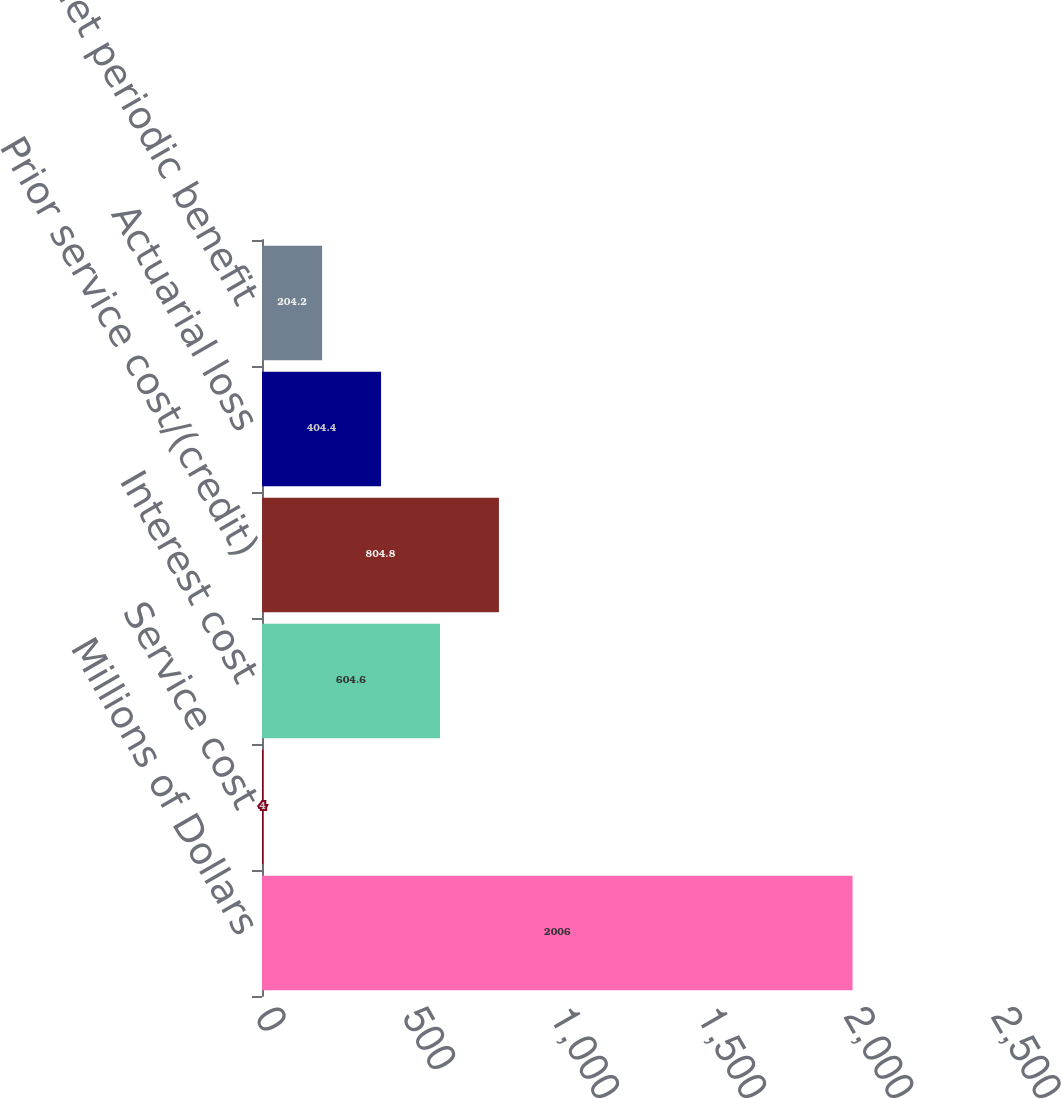Convert chart. <chart><loc_0><loc_0><loc_500><loc_500><bar_chart><fcel>Millions of Dollars<fcel>Service cost<fcel>Interest cost<fcel>Prior service cost/(credit)<fcel>Actuarial loss<fcel>Net periodic benefit<nl><fcel>2006<fcel>4<fcel>604.6<fcel>804.8<fcel>404.4<fcel>204.2<nl></chart> 